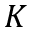Convert formula to latex. <formula><loc_0><loc_0><loc_500><loc_500>K</formula> 